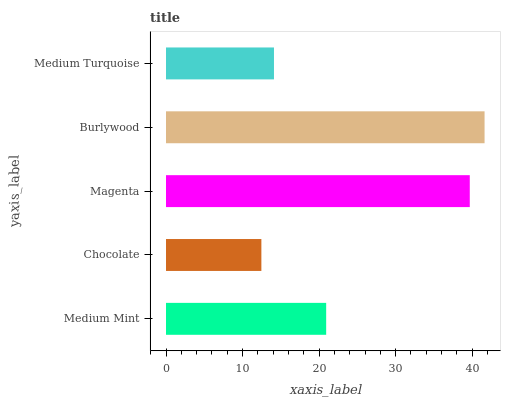Is Chocolate the minimum?
Answer yes or no. Yes. Is Burlywood the maximum?
Answer yes or no. Yes. Is Magenta the minimum?
Answer yes or no. No. Is Magenta the maximum?
Answer yes or no. No. Is Magenta greater than Chocolate?
Answer yes or no. Yes. Is Chocolate less than Magenta?
Answer yes or no. Yes. Is Chocolate greater than Magenta?
Answer yes or no. No. Is Magenta less than Chocolate?
Answer yes or no. No. Is Medium Mint the high median?
Answer yes or no. Yes. Is Medium Mint the low median?
Answer yes or no. Yes. Is Chocolate the high median?
Answer yes or no. No. Is Magenta the low median?
Answer yes or no. No. 